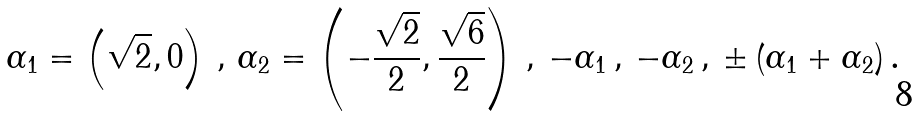Convert formula to latex. <formula><loc_0><loc_0><loc_500><loc_500>\alpha _ { 1 } = \left ( \sqrt { 2 } , 0 \right ) \, , \, \alpha _ { 2 } = \left ( - \frac { \sqrt { 2 } } { 2 } , \frac { \sqrt { 6 } } { 2 } \right ) \, , \, - \alpha _ { 1 } \, , \, - \alpha _ { 2 } \, , \, \pm \left ( \alpha _ { 1 } + \alpha _ { 2 } \right ) .</formula> 